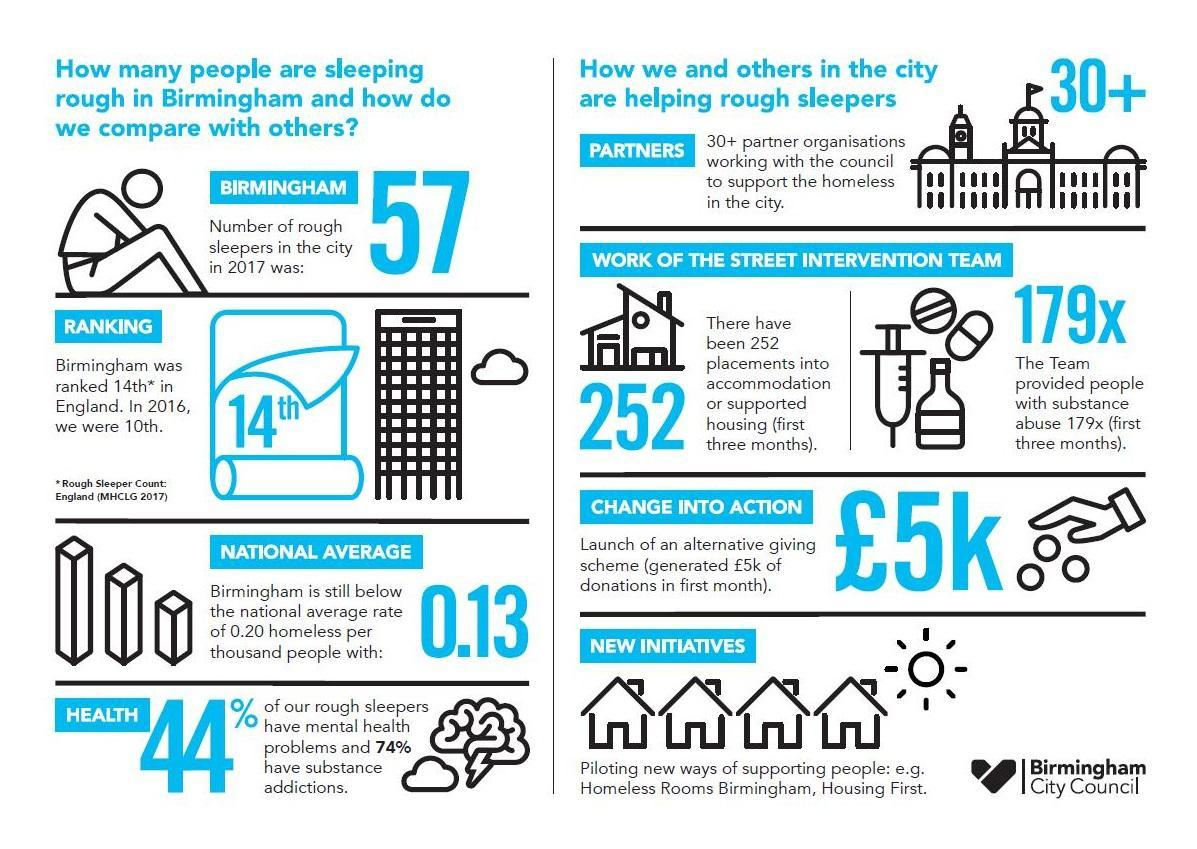What is the average rate of homeless people in Birmingham city in 2017?
Answer the question with a short phrase. 0.13 What percentage of rough sleepers in Birmingham city have substance addictions in 2017? 74% What is the ranking of Birmingham city in the rough sleeper count in 2016? 10th What percentage of rough sleepers in Birmingham city do not have mental health problems in 2017? 56% 